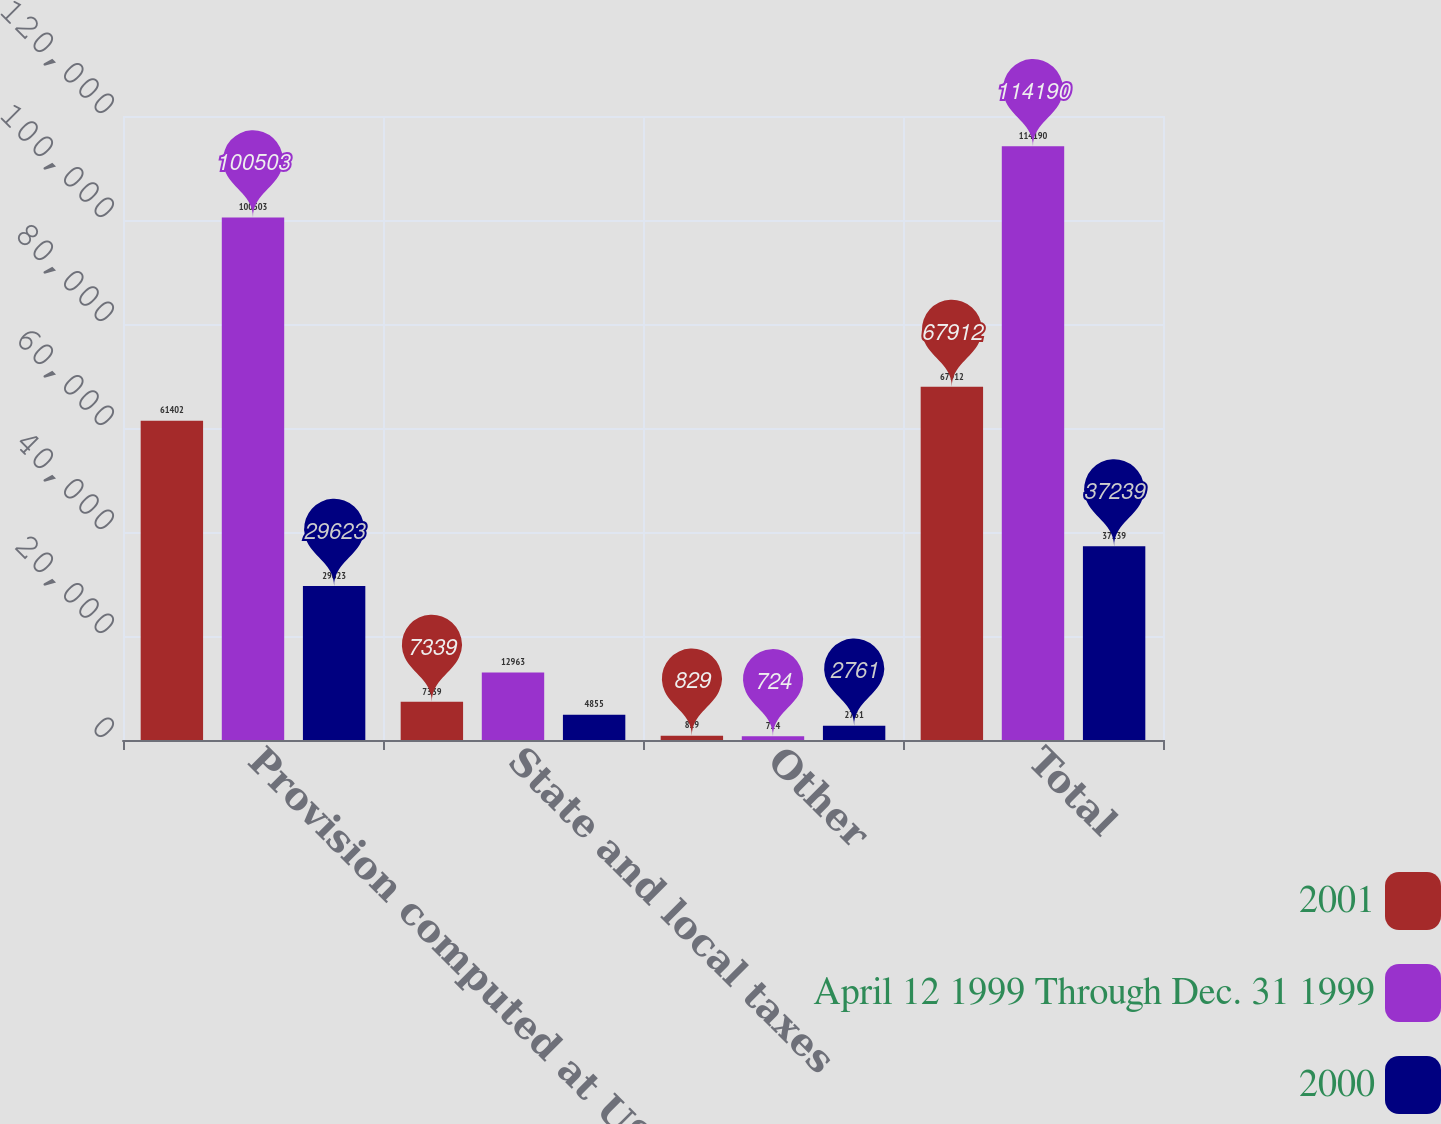Convert chart. <chart><loc_0><loc_0><loc_500><loc_500><stacked_bar_chart><ecel><fcel>Provision computed at US<fcel>State and local taxes<fcel>Other<fcel>Total<nl><fcel>2001<fcel>61402<fcel>7339<fcel>829<fcel>67912<nl><fcel>April 12 1999 Through Dec. 31 1999<fcel>100503<fcel>12963<fcel>724<fcel>114190<nl><fcel>2000<fcel>29623<fcel>4855<fcel>2761<fcel>37239<nl></chart> 